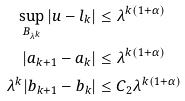<formula> <loc_0><loc_0><loc_500><loc_500>\sup _ { B _ { \lambda ^ { k } } } | u - l _ { k } | & \leq \lambda ^ { k ( 1 + \alpha ) } \\ | a _ { k + 1 } - a _ { k } | & \leq \lambda ^ { k ( 1 + \alpha ) } \\ \lambda ^ { k } | b _ { k + 1 } - b _ { k } | & \leq C _ { 2 } \lambda ^ { k ( 1 + \alpha ) }</formula> 